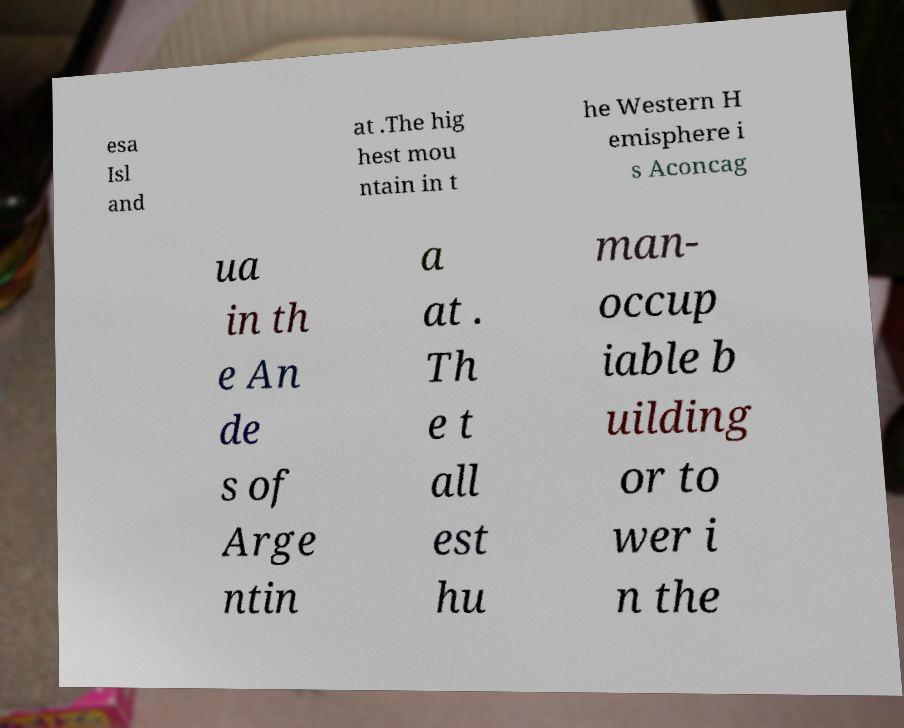For documentation purposes, I need the text within this image transcribed. Could you provide that? esa Isl and at .The hig hest mou ntain in t he Western H emisphere i s Aconcag ua in th e An de s of Arge ntin a at . Th e t all est hu man- occup iable b uilding or to wer i n the 